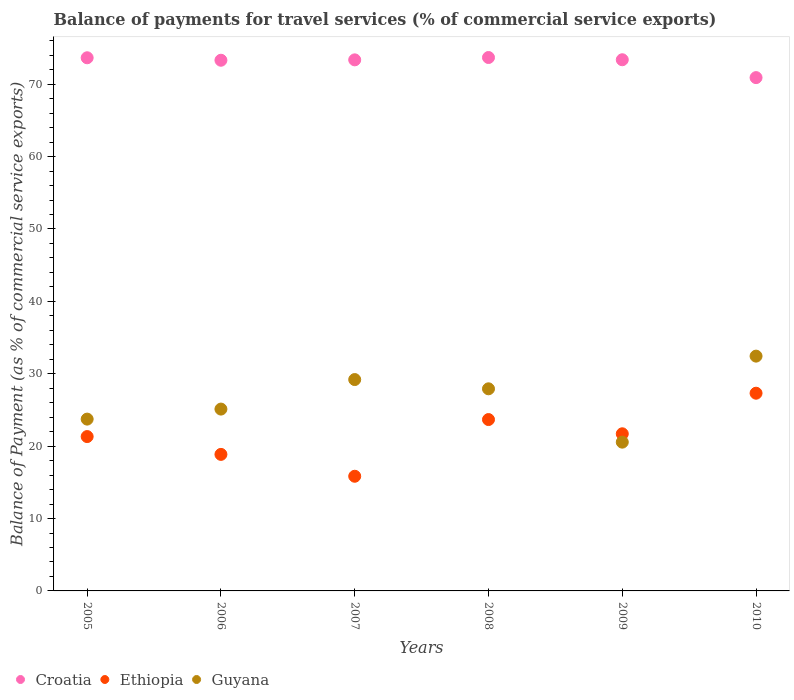Is the number of dotlines equal to the number of legend labels?
Offer a terse response. Yes. What is the balance of payments for travel services in Ethiopia in 2009?
Offer a very short reply. 21.71. Across all years, what is the maximum balance of payments for travel services in Guyana?
Your response must be concise. 32.44. Across all years, what is the minimum balance of payments for travel services in Ethiopia?
Make the answer very short. 15.84. In which year was the balance of payments for travel services in Guyana maximum?
Keep it short and to the point. 2010. What is the total balance of payments for travel services in Guyana in the graph?
Your response must be concise. 158.96. What is the difference between the balance of payments for travel services in Guyana in 2006 and that in 2007?
Provide a short and direct response. -4.08. What is the difference between the balance of payments for travel services in Guyana in 2009 and the balance of payments for travel services in Ethiopia in 2007?
Offer a very short reply. 4.71. What is the average balance of payments for travel services in Guyana per year?
Your answer should be very brief. 26.49. In the year 2007, what is the difference between the balance of payments for travel services in Ethiopia and balance of payments for travel services in Croatia?
Your answer should be compact. -57.52. What is the ratio of the balance of payments for travel services in Guyana in 2005 to that in 2009?
Offer a very short reply. 1.15. Is the difference between the balance of payments for travel services in Ethiopia in 2007 and 2010 greater than the difference between the balance of payments for travel services in Croatia in 2007 and 2010?
Give a very brief answer. No. What is the difference between the highest and the second highest balance of payments for travel services in Guyana?
Provide a short and direct response. 3.24. What is the difference between the highest and the lowest balance of payments for travel services in Guyana?
Your answer should be very brief. 11.88. In how many years, is the balance of payments for travel services in Ethiopia greater than the average balance of payments for travel services in Ethiopia taken over all years?
Your answer should be very brief. 3. Is it the case that in every year, the sum of the balance of payments for travel services in Guyana and balance of payments for travel services in Croatia  is greater than the balance of payments for travel services in Ethiopia?
Your response must be concise. Yes. Does the balance of payments for travel services in Ethiopia monotonically increase over the years?
Your answer should be compact. No. How many dotlines are there?
Provide a succinct answer. 3. What is the difference between two consecutive major ticks on the Y-axis?
Provide a short and direct response. 10. Are the values on the major ticks of Y-axis written in scientific E-notation?
Offer a terse response. No. Does the graph contain any zero values?
Your response must be concise. No. Does the graph contain grids?
Offer a terse response. No. Where does the legend appear in the graph?
Give a very brief answer. Bottom left. How many legend labels are there?
Your answer should be compact. 3. What is the title of the graph?
Your response must be concise. Balance of payments for travel services (% of commercial service exports). What is the label or title of the Y-axis?
Your answer should be very brief. Balance of Payment (as % of commercial service exports). What is the Balance of Payment (as % of commercial service exports) of Croatia in 2005?
Offer a very short reply. 73.65. What is the Balance of Payment (as % of commercial service exports) in Ethiopia in 2005?
Provide a short and direct response. 21.32. What is the Balance of Payment (as % of commercial service exports) of Guyana in 2005?
Ensure brevity in your answer.  23.73. What is the Balance of Payment (as % of commercial service exports) of Croatia in 2006?
Make the answer very short. 73.31. What is the Balance of Payment (as % of commercial service exports) of Ethiopia in 2006?
Your answer should be compact. 18.86. What is the Balance of Payment (as % of commercial service exports) in Guyana in 2006?
Keep it short and to the point. 25.12. What is the Balance of Payment (as % of commercial service exports) in Croatia in 2007?
Ensure brevity in your answer.  73.36. What is the Balance of Payment (as % of commercial service exports) in Ethiopia in 2007?
Offer a terse response. 15.84. What is the Balance of Payment (as % of commercial service exports) of Guyana in 2007?
Your answer should be compact. 29.2. What is the Balance of Payment (as % of commercial service exports) of Croatia in 2008?
Give a very brief answer. 73.69. What is the Balance of Payment (as % of commercial service exports) in Ethiopia in 2008?
Your answer should be compact. 23.67. What is the Balance of Payment (as % of commercial service exports) of Guyana in 2008?
Ensure brevity in your answer.  27.92. What is the Balance of Payment (as % of commercial service exports) of Croatia in 2009?
Make the answer very short. 73.38. What is the Balance of Payment (as % of commercial service exports) in Ethiopia in 2009?
Provide a short and direct response. 21.71. What is the Balance of Payment (as % of commercial service exports) of Guyana in 2009?
Ensure brevity in your answer.  20.55. What is the Balance of Payment (as % of commercial service exports) of Croatia in 2010?
Ensure brevity in your answer.  70.91. What is the Balance of Payment (as % of commercial service exports) in Ethiopia in 2010?
Offer a terse response. 27.31. What is the Balance of Payment (as % of commercial service exports) of Guyana in 2010?
Give a very brief answer. 32.44. Across all years, what is the maximum Balance of Payment (as % of commercial service exports) of Croatia?
Keep it short and to the point. 73.69. Across all years, what is the maximum Balance of Payment (as % of commercial service exports) of Ethiopia?
Your answer should be very brief. 27.31. Across all years, what is the maximum Balance of Payment (as % of commercial service exports) of Guyana?
Offer a terse response. 32.44. Across all years, what is the minimum Balance of Payment (as % of commercial service exports) in Croatia?
Your response must be concise. 70.91. Across all years, what is the minimum Balance of Payment (as % of commercial service exports) of Ethiopia?
Offer a terse response. 15.84. Across all years, what is the minimum Balance of Payment (as % of commercial service exports) in Guyana?
Offer a very short reply. 20.55. What is the total Balance of Payment (as % of commercial service exports) of Croatia in the graph?
Provide a short and direct response. 438.3. What is the total Balance of Payment (as % of commercial service exports) of Ethiopia in the graph?
Give a very brief answer. 128.72. What is the total Balance of Payment (as % of commercial service exports) of Guyana in the graph?
Your answer should be very brief. 158.96. What is the difference between the Balance of Payment (as % of commercial service exports) in Croatia in 2005 and that in 2006?
Your answer should be very brief. 0.34. What is the difference between the Balance of Payment (as % of commercial service exports) of Ethiopia in 2005 and that in 2006?
Offer a terse response. 2.46. What is the difference between the Balance of Payment (as % of commercial service exports) of Guyana in 2005 and that in 2006?
Offer a very short reply. -1.38. What is the difference between the Balance of Payment (as % of commercial service exports) of Croatia in 2005 and that in 2007?
Give a very brief answer. 0.29. What is the difference between the Balance of Payment (as % of commercial service exports) of Ethiopia in 2005 and that in 2007?
Provide a succinct answer. 5.48. What is the difference between the Balance of Payment (as % of commercial service exports) of Guyana in 2005 and that in 2007?
Offer a terse response. -5.46. What is the difference between the Balance of Payment (as % of commercial service exports) in Croatia in 2005 and that in 2008?
Provide a succinct answer. -0.04. What is the difference between the Balance of Payment (as % of commercial service exports) of Ethiopia in 2005 and that in 2008?
Ensure brevity in your answer.  -2.35. What is the difference between the Balance of Payment (as % of commercial service exports) in Guyana in 2005 and that in 2008?
Ensure brevity in your answer.  -4.19. What is the difference between the Balance of Payment (as % of commercial service exports) in Croatia in 2005 and that in 2009?
Provide a short and direct response. 0.27. What is the difference between the Balance of Payment (as % of commercial service exports) of Ethiopia in 2005 and that in 2009?
Offer a very short reply. -0.38. What is the difference between the Balance of Payment (as % of commercial service exports) of Guyana in 2005 and that in 2009?
Your answer should be compact. 3.18. What is the difference between the Balance of Payment (as % of commercial service exports) of Croatia in 2005 and that in 2010?
Provide a succinct answer. 2.74. What is the difference between the Balance of Payment (as % of commercial service exports) of Ethiopia in 2005 and that in 2010?
Ensure brevity in your answer.  -5.99. What is the difference between the Balance of Payment (as % of commercial service exports) of Guyana in 2005 and that in 2010?
Offer a terse response. -8.7. What is the difference between the Balance of Payment (as % of commercial service exports) in Croatia in 2006 and that in 2007?
Offer a terse response. -0.05. What is the difference between the Balance of Payment (as % of commercial service exports) of Ethiopia in 2006 and that in 2007?
Offer a very short reply. 3.02. What is the difference between the Balance of Payment (as % of commercial service exports) in Guyana in 2006 and that in 2007?
Your answer should be very brief. -4.08. What is the difference between the Balance of Payment (as % of commercial service exports) in Croatia in 2006 and that in 2008?
Offer a very short reply. -0.38. What is the difference between the Balance of Payment (as % of commercial service exports) in Ethiopia in 2006 and that in 2008?
Give a very brief answer. -4.81. What is the difference between the Balance of Payment (as % of commercial service exports) in Guyana in 2006 and that in 2008?
Keep it short and to the point. -2.8. What is the difference between the Balance of Payment (as % of commercial service exports) in Croatia in 2006 and that in 2009?
Make the answer very short. -0.07. What is the difference between the Balance of Payment (as % of commercial service exports) of Ethiopia in 2006 and that in 2009?
Provide a succinct answer. -2.85. What is the difference between the Balance of Payment (as % of commercial service exports) in Guyana in 2006 and that in 2009?
Offer a terse response. 4.57. What is the difference between the Balance of Payment (as % of commercial service exports) in Croatia in 2006 and that in 2010?
Offer a terse response. 2.4. What is the difference between the Balance of Payment (as % of commercial service exports) in Ethiopia in 2006 and that in 2010?
Offer a terse response. -8.45. What is the difference between the Balance of Payment (as % of commercial service exports) in Guyana in 2006 and that in 2010?
Keep it short and to the point. -7.32. What is the difference between the Balance of Payment (as % of commercial service exports) of Croatia in 2007 and that in 2008?
Provide a succinct answer. -0.32. What is the difference between the Balance of Payment (as % of commercial service exports) of Ethiopia in 2007 and that in 2008?
Provide a succinct answer. -7.83. What is the difference between the Balance of Payment (as % of commercial service exports) in Guyana in 2007 and that in 2008?
Offer a terse response. 1.28. What is the difference between the Balance of Payment (as % of commercial service exports) in Croatia in 2007 and that in 2009?
Provide a short and direct response. -0.02. What is the difference between the Balance of Payment (as % of commercial service exports) in Ethiopia in 2007 and that in 2009?
Provide a short and direct response. -5.87. What is the difference between the Balance of Payment (as % of commercial service exports) in Guyana in 2007 and that in 2009?
Give a very brief answer. 8.65. What is the difference between the Balance of Payment (as % of commercial service exports) in Croatia in 2007 and that in 2010?
Your response must be concise. 2.45. What is the difference between the Balance of Payment (as % of commercial service exports) of Ethiopia in 2007 and that in 2010?
Provide a short and direct response. -11.47. What is the difference between the Balance of Payment (as % of commercial service exports) in Guyana in 2007 and that in 2010?
Ensure brevity in your answer.  -3.24. What is the difference between the Balance of Payment (as % of commercial service exports) of Croatia in 2008 and that in 2009?
Give a very brief answer. 0.31. What is the difference between the Balance of Payment (as % of commercial service exports) of Ethiopia in 2008 and that in 2009?
Your answer should be compact. 1.97. What is the difference between the Balance of Payment (as % of commercial service exports) in Guyana in 2008 and that in 2009?
Provide a succinct answer. 7.37. What is the difference between the Balance of Payment (as % of commercial service exports) of Croatia in 2008 and that in 2010?
Ensure brevity in your answer.  2.78. What is the difference between the Balance of Payment (as % of commercial service exports) in Ethiopia in 2008 and that in 2010?
Your answer should be compact. -3.64. What is the difference between the Balance of Payment (as % of commercial service exports) in Guyana in 2008 and that in 2010?
Make the answer very short. -4.52. What is the difference between the Balance of Payment (as % of commercial service exports) of Croatia in 2009 and that in 2010?
Keep it short and to the point. 2.47. What is the difference between the Balance of Payment (as % of commercial service exports) in Ethiopia in 2009 and that in 2010?
Offer a very short reply. -5.61. What is the difference between the Balance of Payment (as % of commercial service exports) of Guyana in 2009 and that in 2010?
Give a very brief answer. -11.88. What is the difference between the Balance of Payment (as % of commercial service exports) in Croatia in 2005 and the Balance of Payment (as % of commercial service exports) in Ethiopia in 2006?
Ensure brevity in your answer.  54.79. What is the difference between the Balance of Payment (as % of commercial service exports) of Croatia in 2005 and the Balance of Payment (as % of commercial service exports) of Guyana in 2006?
Offer a terse response. 48.53. What is the difference between the Balance of Payment (as % of commercial service exports) in Ethiopia in 2005 and the Balance of Payment (as % of commercial service exports) in Guyana in 2006?
Your response must be concise. -3.8. What is the difference between the Balance of Payment (as % of commercial service exports) in Croatia in 2005 and the Balance of Payment (as % of commercial service exports) in Ethiopia in 2007?
Offer a very short reply. 57.81. What is the difference between the Balance of Payment (as % of commercial service exports) of Croatia in 2005 and the Balance of Payment (as % of commercial service exports) of Guyana in 2007?
Ensure brevity in your answer.  44.45. What is the difference between the Balance of Payment (as % of commercial service exports) in Ethiopia in 2005 and the Balance of Payment (as % of commercial service exports) in Guyana in 2007?
Make the answer very short. -7.88. What is the difference between the Balance of Payment (as % of commercial service exports) of Croatia in 2005 and the Balance of Payment (as % of commercial service exports) of Ethiopia in 2008?
Your answer should be very brief. 49.98. What is the difference between the Balance of Payment (as % of commercial service exports) of Croatia in 2005 and the Balance of Payment (as % of commercial service exports) of Guyana in 2008?
Give a very brief answer. 45.73. What is the difference between the Balance of Payment (as % of commercial service exports) of Ethiopia in 2005 and the Balance of Payment (as % of commercial service exports) of Guyana in 2008?
Keep it short and to the point. -6.6. What is the difference between the Balance of Payment (as % of commercial service exports) in Croatia in 2005 and the Balance of Payment (as % of commercial service exports) in Ethiopia in 2009?
Give a very brief answer. 51.94. What is the difference between the Balance of Payment (as % of commercial service exports) in Croatia in 2005 and the Balance of Payment (as % of commercial service exports) in Guyana in 2009?
Your response must be concise. 53.1. What is the difference between the Balance of Payment (as % of commercial service exports) of Ethiopia in 2005 and the Balance of Payment (as % of commercial service exports) of Guyana in 2009?
Offer a terse response. 0.77. What is the difference between the Balance of Payment (as % of commercial service exports) in Croatia in 2005 and the Balance of Payment (as % of commercial service exports) in Ethiopia in 2010?
Provide a succinct answer. 46.34. What is the difference between the Balance of Payment (as % of commercial service exports) in Croatia in 2005 and the Balance of Payment (as % of commercial service exports) in Guyana in 2010?
Offer a very short reply. 41.22. What is the difference between the Balance of Payment (as % of commercial service exports) in Ethiopia in 2005 and the Balance of Payment (as % of commercial service exports) in Guyana in 2010?
Offer a very short reply. -11.11. What is the difference between the Balance of Payment (as % of commercial service exports) of Croatia in 2006 and the Balance of Payment (as % of commercial service exports) of Ethiopia in 2007?
Provide a short and direct response. 57.47. What is the difference between the Balance of Payment (as % of commercial service exports) in Croatia in 2006 and the Balance of Payment (as % of commercial service exports) in Guyana in 2007?
Your response must be concise. 44.11. What is the difference between the Balance of Payment (as % of commercial service exports) in Ethiopia in 2006 and the Balance of Payment (as % of commercial service exports) in Guyana in 2007?
Provide a short and direct response. -10.34. What is the difference between the Balance of Payment (as % of commercial service exports) of Croatia in 2006 and the Balance of Payment (as % of commercial service exports) of Ethiopia in 2008?
Your answer should be very brief. 49.64. What is the difference between the Balance of Payment (as % of commercial service exports) of Croatia in 2006 and the Balance of Payment (as % of commercial service exports) of Guyana in 2008?
Provide a short and direct response. 45.39. What is the difference between the Balance of Payment (as % of commercial service exports) in Ethiopia in 2006 and the Balance of Payment (as % of commercial service exports) in Guyana in 2008?
Ensure brevity in your answer.  -9.06. What is the difference between the Balance of Payment (as % of commercial service exports) in Croatia in 2006 and the Balance of Payment (as % of commercial service exports) in Ethiopia in 2009?
Provide a succinct answer. 51.6. What is the difference between the Balance of Payment (as % of commercial service exports) in Croatia in 2006 and the Balance of Payment (as % of commercial service exports) in Guyana in 2009?
Offer a very short reply. 52.76. What is the difference between the Balance of Payment (as % of commercial service exports) of Ethiopia in 2006 and the Balance of Payment (as % of commercial service exports) of Guyana in 2009?
Offer a terse response. -1.69. What is the difference between the Balance of Payment (as % of commercial service exports) of Croatia in 2006 and the Balance of Payment (as % of commercial service exports) of Ethiopia in 2010?
Provide a succinct answer. 46. What is the difference between the Balance of Payment (as % of commercial service exports) of Croatia in 2006 and the Balance of Payment (as % of commercial service exports) of Guyana in 2010?
Keep it short and to the point. 40.87. What is the difference between the Balance of Payment (as % of commercial service exports) of Ethiopia in 2006 and the Balance of Payment (as % of commercial service exports) of Guyana in 2010?
Provide a succinct answer. -13.57. What is the difference between the Balance of Payment (as % of commercial service exports) in Croatia in 2007 and the Balance of Payment (as % of commercial service exports) in Ethiopia in 2008?
Your answer should be very brief. 49.69. What is the difference between the Balance of Payment (as % of commercial service exports) in Croatia in 2007 and the Balance of Payment (as % of commercial service exports) in Guyana in 2008?
Keep it short and to the point. 45.44. What is the difference between the Balance of Payment (as % of commercial service exports) of Ethiopia in 2007 and the Balance of Payment (as % of commercial service exports) of Guyana in 2008?
Provide a short and direct response. -12.08. What is the difference between the Balance of Payment (as % of commercial service exports) in Croatia in 2007 and the Balance of Payment (as % of commercial service exports) in Ethiopia in 2009?
Offer a terse response. 51.66. What is the difference between the Balance of Payment (as % of commercial service exports) in Croatia in 2007 and the Balance of Payment (as % of commercial service exports) in Guyana in 2009?
Ensure brevity in your answer.  52.81. What is the difference between the Balance of Payment (as % of commercial service exports) of Ethiopia in 2007 and the Balance of Payment (as % of commercial service exports) of Guyana in 2009?
Keep it short and to the point. -4.71. What is the difference between the Balance of Payment (as % of commercial service exports) in Croatia in 2007 and the Balance of Payment (as % of commercial service exports) in Ethiopia in 2010?
Your answer should be very brief. 46.05. What is the difference between the Balance of Payment (as % of commercial service exports) of Croatia in 2007 and the Balance of Payment (as % of commercial service exports) of Guyana in 2010?
Provide a short and direct response. 40.93. What is the difference between the Balance of Payment (as % of commercial service exports) in Ethiopia in 2007 and the Balance of Payment (as % of commercial service exports) in Guyana in 2010?
Provide a short and direct response. -16.6. What is the difference between the Balance of Payment (as % of commercial service exports) of Croatia in 2008 and the Balance of Payment (as % of commercial service exports) of Ethiopia in 2009?
Ensure brevity in your answer.  51.98. What is the difference between the Balance of Payment (as % of commercial service exports) in Croatia in 2008 and the Balance of Payment (as % of commercial service exports) in Guyana in 2009?
Your answer should be compact. 53.14. What is the difference between the Balance of Payment (as % of commercial service exports) of Ethiopia in 2008 and the Balance of Payment (as % of commercial service exports) of Guyana in 2009?
Offer a terse response. 3.12. What is the difference between the Balance of Payment (as % of commercial service exports) of Croatia in 2008 and the Balance of Payment (as % of commercial service exports) of Ethiopia in 2010?
Offer a terse response. 46.37. What is the difference between the Balance of Payment (as % of commercial service exports) of Croatia in 2008 and the Balance of Payment (as % of commercial service exports) of Guyana in 2010?
Your response must be concise. 41.25. What is the difference between the Balance of Payment (as % of commercial service exports) of Ethiopia in 2008 and the Balance of Payment (as % of commercial service exports) of Guyana in 2010?
Provide a short and direct response. -8.76. What is the difference between the Balance of Payment (as % of commercial service exports) of Croatia in 2009 and the Balance of Payment (as % of commercial service exports) of Ethiopia in 2010?
Ensure brevity in your answer.  46.06. What is the difference between the Balance of Payment (as % of commercial service exports) of Croatia in 2009 and the Balance of Payment (as % of commercial service exports) of Guyana in 2010?
Your answer should be compact. 40.94. What is the difference between the Balance of Payment (as % of commercial service exports) of Ethiopia in 2009 and the Balance of Payment (as % of commercial service exports) of Guyana in 2010?
Your answer should be very brief. -10.73. What is the average Balance of Payment (as % of commercial service exports) of Croatia per year?
Your response must be concise. 73.05. What is the average Balance of Payment (as % of commercial service exports) of Ethiopia per year?
Offer a very short reply. 21.45. What is the average Balance of Payment (as % of commercial service exports) in Guyana per year?
Provide a succinct answer. 26.49. In the year 2005, what is the difference between the Balance of Payment (as % of commercial service exports) of Croatia and Balance of Payment (as % of commercial service exports) of Ethiopia?
Give a very brief answer. 52.33. In the year 2005, what is the difference between the Balance of Payment (as % of commercial service exports) in Croatia and Balance of Payment (as % of commercial service exports) in Guyana?
Ensure brevity in your answer.  49.92. In the year 2005, what is the difference between the Balance of Payment (as % of commercial service exports) of Ethiopia and Balance of Payment (as % of commercial service exports) of Guyana?
Offer a very short reply. -2.41. In the year 2006, what is the difference between the Balance of Payment (as % of commercial service exports) in Croatia and Balance of Payment (as % of commercial service exports) in Ethiopia?
Keep it short and to the point. 54.45. In the year 2006, what is the difference between the Balance of Payment (as % of commercial service exports) of Croatia and Balance of Payment (as % of commercial service exports) of Guyana?
Provide a succinct answer. 48.19. In the year 2006, what is the difference between the Balance of Payment (as % of commercial service exports) of Ethiopia and Balance of Payment (as % of commercial service exports) of Guyana?
Provide a short and direct response. -6.26. In the year 2007, what is the difference between the Balance of Payment (as % of commercial service exports) in Croatia and Balance of Payment (as % of commercial service exports) in Ethiopia?
Make the answer very short. 57.52. In the year 2007, what is the difference between the Balance of Payment (as % of commercial service exports) of Croatia and Balance of Payment (as % of commercial service exports) of Guyana?
Give a very brief answer. 44.16. In the year 2007, what is the difference between the Balance of Payment (as % of commercial service exports) in Ethiopia and Balance of Payment (as % of commercial service exports) in Guyana?
Your answer should be very brief. -13.36. In the year 2008, what is the difference between the Balance of Payment (as % of commercial service exports) of Croatia and Balance of Payment (as % of commercial service exports) of Ethiopia?
Give a very brief answer. 50.01. In the year 2008, what is the difference between the Balance of Payment (as % of commercial service exports) of Croatia and Balance of Payment (as % of commercial service exports) of Guyana?
Provide a short and direct response. 45.77. In the year 2008, what is the difference between the Balance of Payment (as % of commercial service exports) in Ethiopia and Balance of Payment (as % of commercial service exports) in Guyana?
Your answer should be compact. -4.25. In the year 2009, what is the difference between the Balance of Payment (as % of commercial service exports) of Croatia and Balance of Payment (as % of commercial service exports) of Ethiopia?
Ensure brevity in your answer.  51.67. In the year 2009, what is the difference between the Balance of Payment (as % of commercial service exports) of Croatia and Balance of Payment (as % of commercial service exports) of Guyana?
Provide a succinct answer. 52.83. In the year 2009, what is the difference between the Balance of Payment (as % of commercial service exports) of Ethiopia and Balance of Payment (as % of commercial service exports) of Guyana?
Your answer should be very brief. 1.16. In the year 2010, what is the difference between the Balance of Payment (as % of commercial service exports) in Croatia and Balance of Payment (as % of commercial service exports) in Ethiopia?
Offer a very short reply. 43.6. In the year 2010, what is the difference between the Balance of Payment (as % of commercial service exports) in Croatia and Balance of Payment (as % of commercial service exports) in Guyana?
Ensure brevity in your answer.  38.47. In the year 2010, what is the difference between the Balance of Payment (as % of commercial service exports) in Ethiopia and Balance of Payment (as % of commercial service exports) in Guyana?
Keep it short and to the point. -5.12. What is the ratio of the Balance of Payment (as % of commercial service exports) in Ethiopia in 2005 to that in 2006?
Your answer should be very brief. 1.13. What is the ratio of the Balance of Payment (as % of commercial service exports) in Guyana in 2005 to that in 2006?
Keep it short and to the point. 0.94. What is the ratio of the Balance of Payment (as % of commercial service exports) of Croatia in 2005 to that in 2007?
Provide a succinct answer. 1. What is the ratio of the Balance of Payment (as % of commercial service exports) in Ethiopia in 2005 to that in 2007?
Keep it short and to the point. 1.35. What is the ratio of the Balance of Payment (as % of commercial service exports) in Guyana in 2005 to that in 2007?
Provide a short and direct response. 0.81. What is the ratio of the Balance of Payment (as % of commercial service exports) of Ethiopia in 2005 to that in 2008?
Your answer should be compact. 0.9. What is the ratio of the Balance of Payment (as % of commercial service exports) of Guyana in 2005 to that in 2008?
Offer a very short reply. 0.85. What is the ratio of the Balance of Payment (as % of commercial service exports) of Croatia in 2005 to that in 2009?
Offer a terse response. 1. What is the ratio of the Balance of Payment (as % of commercial service exports) in Ethiopia in 2005 to that in 2009?
Your answer should be compact. 0.98. What is the ratio of the Balance of Payment (as % of commercial service exports) of Guyana in 2005 to that in 2009?
Keep it short and to the point. 1.15. What is the ratio of the Balance of Payment (as % of commercial service exports) in Croatia in 2005 to that in 2010?
Offer a terse response. 1.04. What is the ratio of the Balance of Payment (as % of commercial service exports) of Ethiopia in 2005 to that in 2010?
Keep it short and to the point. 0.78. What is the ratio of the Balance of Payment (as % of commercial service exports) in Guyana in 2005 to that in 2010?
Provide a succinct answer. 0.73. What is the ratio of the Balance of Payment (as % of commercial service exports) of Ethiopia in 2006 to that in 2007?
Keep it short and to the point. 1.19. What is the ratio of the Balance of Payment (as % of commercial service exports) of Guyana in 2006 to that in 2007?
Offer a terse response. 0.86. What is the ratio of the Balance of Payment (as % of commercial service exports) in Ethiopia in 2006 to that in 2008?
Offer a terse response. 0.8. What is the ratio of the Balance of Payment (as % of commercial service exports) of Guyana in 2006 to that in 2008?
Keep it short and to the point. 0.9. What is the ratio of the Balance of Payment (as % of commercial service exports) of Croatia in 2006 to that in 2009?
Keep it short and to the point. 1. What is the ratio of the Balance of Payment (as % of commercial service exports) in Ethiopia in 2006 to that in 2009?
Give a very brief answer. 0.87. What is the ratio of the Balance of Payment (as % of commercial service exports) in Guyana in 2006 to that in 2009?
Provide a short and direct response. 1.22. What is the ratio of the Balance of Payment (as % of commercial service exports) of Croatia in 2006 to that in 2010?
Make the answer very short. 1.03. What is the ratio of the Balance of Payment (as % of commercial service exports) of Ethiopia in 2006 to that in 2010?
Offer a terse response. 0.69. What is the ratio of the Balance of Payment (as % of commercial service exports) in Guyana in 2006 to that in 2010?
Your answer should be compact. 0.77. What is the ratio of the Balance of Payment (as % of commercial service exports) of Croatia in 2007 to that in 2008?
Offer a very short reply. 1. What is the ratio of the Balance of Payment (as % of commercial service exports) of Ethiopia in 2007 to that in 2008?
Your answer should be compact. 0.67. What is the ratio of the Balance of Payment (as % of commercial service exports) in Guyana in 2007 to that in 2008?
Keep it short and to the point. 1.05. What is the ratio of the Balance of Payment (as % of commercial service exports) in Croatia in 2007 to that in 2009?
Your answer should be compact. 1. What is the ratio of the Balance of Payment (as % of commercial service exports) of Ethiopia in 2007 to that in 2009?
Provide a succinct answer. 0.73. What is the ratio of the Balance of Payment (as % of commercial service exports) of Guyana in 2007 to that in 2009?
Ensure brevity in your answer.  1.42. What is the ratio of the Balance of Payment (as % of commercial service exports) in Croatia in 2007 to that in 2010?
Your answer should be compact. 1.03. What is the ratio of the Balance of Payment (as % of commercial service exports) of Ethiopia in 2007 to that in 2010?
Your answer should be compact. 0.58. What is the ratio of the Balance of Payment (as % of commercial service exports) of Guyana in 2007 to that in 2010?
Ensure brevity in your answer.  0.9. What is the ratio of the Balance of Payment (as % of commercial service exports) of Croatia in 2008 to that in 2009?
Provide a succinct answer. 1. What is the ratio of the Balance of Payment (as % of commercial service exports) of Ethiopia in 2008 to that in 2009?
Your answer should be very brief. 1.09. What is the ratio of the Balance of Payment (as % of commercial service exports) of Guyana in 2008 to that in 2009?
Ensure brevity in your answer.  1.36. What is the ratio of the Balance of Payment (as % of commercial service exports) of Croatia in 2008 to that in 2010?
Provide a succinct answer. 1.04. What is the ratio of the Balance of Payment (as % of commercial service exports) of Ethiopia in 2008 to that in 2010?
Keep it short and to the point. 0.87. What is the ratio of the Balance of Payment (as % of commercial service exports) in Guyana in 2008 to that in 2010?
Keep it short and to the point. 0.86. What is the ratio of the Balance of Payment (as % of commercial service exports) in Croatia in 2009 to that in 2010?
Give a very brief answer. 1.03. What is the ratio of the Balance of Payment (as % of commercial service exports) of Ethiopia in 2009 to that in 2010?
Offer a terse response. 0.79. What is the ratio of the Balance of Payment (as % of commercial service exports) of Guyana in 2009 to that in 2010?
Give a very brief answer. 0.63. What is the difference between the highest and the second highest Balance of Payment (as % of commercial service exports) of Croatia?
Your answer should be very brief. 0.04. What is the difference between the highest and the second highest Balance of Payment (as % of commercial service exports) in Ethiopia?
Keep it short and to the point. 3.64. What is the difference between the highest and the second highest Balance of Payment (as % of commercial service exports) in Guyana?
Your answer should be very brief. 3.24. What is the difference between the highest and the lowest Balance of Payment (as % of commercial service exports) of Croatia?
Provide a short and direct response. 2.78. What is the difference between the highest and the lowest Balance of Payment (as % of commercial service exports) of Ethiopia?
Your answer should be very brief. 11.47. What is the difference between the highest and the lowest Balance of Payment (as % of commercial service exports) of Guyana?
Offer a very short reply. 11.88. 